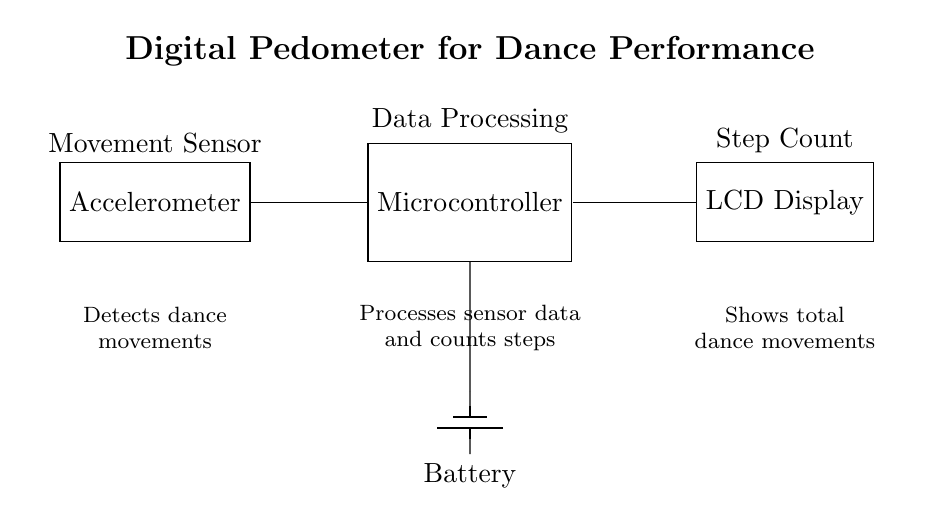What is the main component used to detect movements? The main component for detecting movements in the circuit diagram is the accelerometer, which is labeled as the Movement Sensor. It is responsible for capturing the dance movements.
Answer: Accelerometer How many main components are shown in the diagram? The diagram shows three main components: an accelerometer, a microcontroller, and an LCD display. These components work together to track dance movements.
Answer: Three What does the microcontroller do in the circuit? The microcontroller processes the data it receives from the accelerometer. It counts the detected movements (steps) and prepares this information for display.
Answer: Data Processing What is the output device used to display the step count? The output device in this circuit is the LCD display, which shows the total dance movements counted by the microcontroller.
Answer: LCD Display Which component powers the entire circuit? The component that powers the entire circuit is the battery, providing the necessary voltage and current to the other components.
Answer: Battery How does the data flow in the circuit? The data flows from the accelerometer to the microcontroller for processing, and then from the microcontroller to the LCD display for showing the step count. The sequence is accelerometer to microcontroller to display.
Answer: Accelerometer to microcontroller to display What type of circuit is this described as? This is described as a digital pedometer circuit, specifically designed to track step count during dance performances. It involves digital processing of signals from the sensors.
Answer: Digital Pedometer 